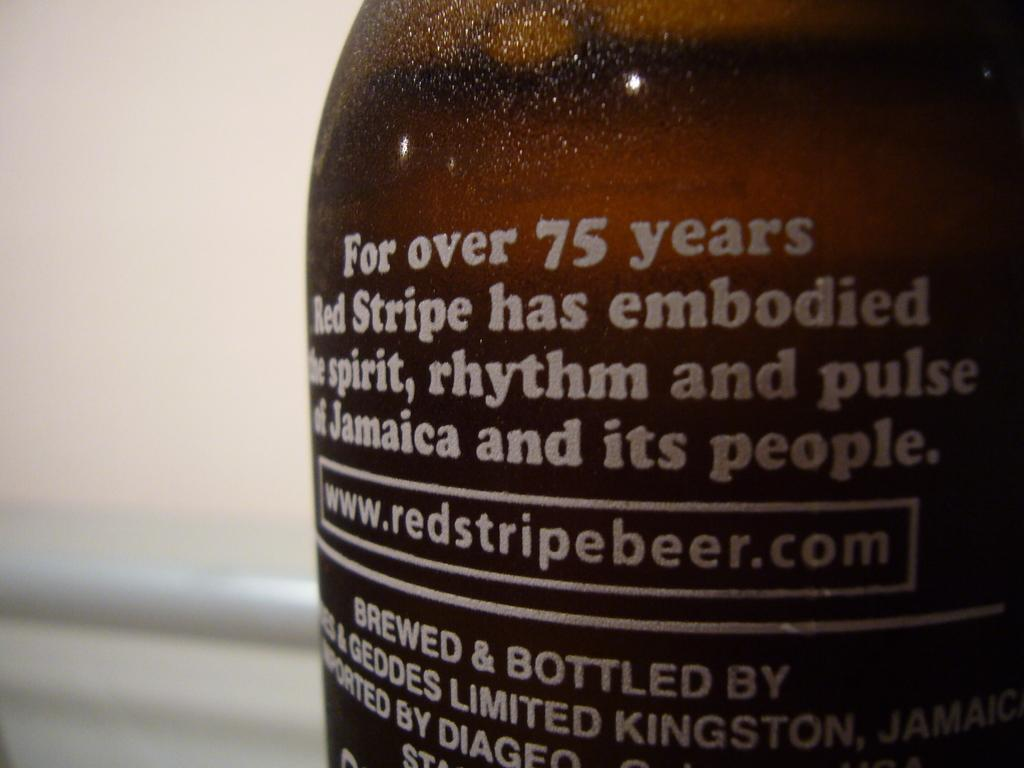<image>
Render a clear and concise summary of the photo. A brown bottle with a description and a website that is www.redstripedbeer.com is on it. 